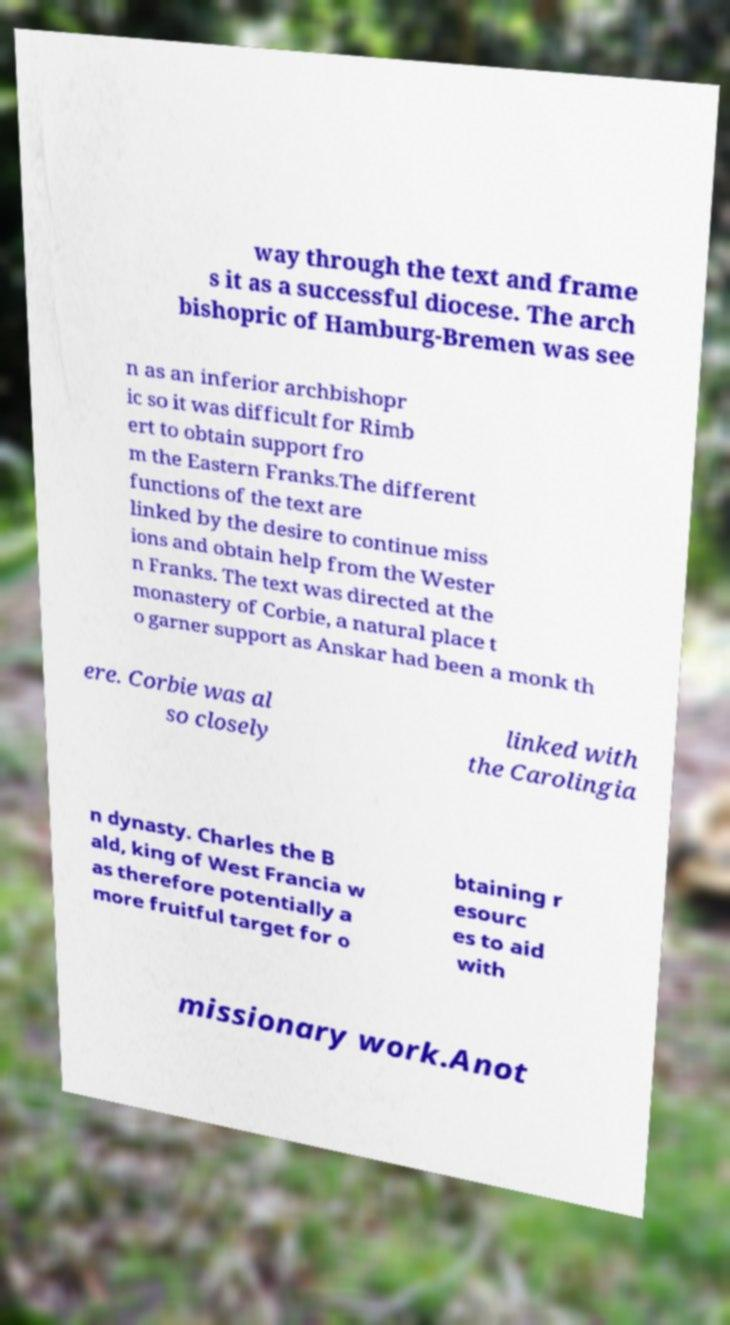Please identify and transcribe the text found in this image. way through the text and frame s it as a successful diocese. The arch bishopric of Hamburg-Bremen was see n as an inferior archbishopr ic so it was difficult for Rimb ert to obtain support fro m the Eastern Franks.The different functions of the text are linked by the desire to continue miss ions and obtain help from the Wester n Franks. The text was directed at the monastery of Corbie, a natural place t o garner support as Anskar had been a monk th ere. Corbie was al so closely linked with the Carolingia n dynasty. Charles the B ald, king of West Francia w as therefore potentially a more fruitful target for o btaining r esourc es to aid with missionary work.Anot 